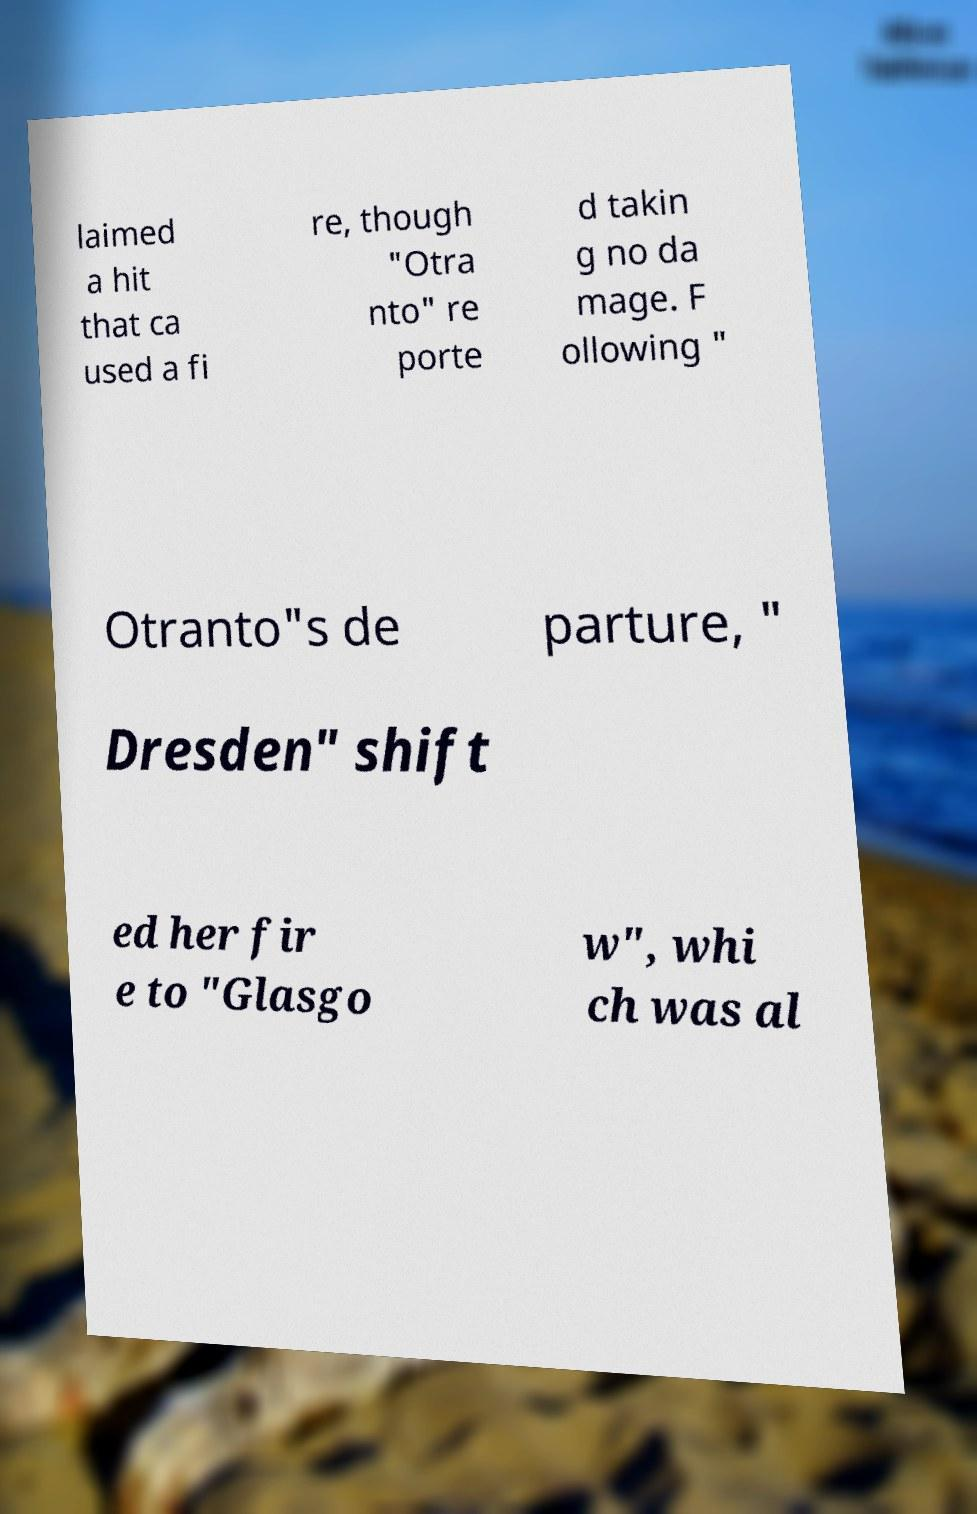Can you accurately transcribe the text from the provided image for me? laimed a hit that ca used a fi re, though "Otra nto" re porte d takin g no da mage. F ollowing " Otranto"s de parture, " Dresden" shift ed her fir e to "Glasgo w", whi ch was al 